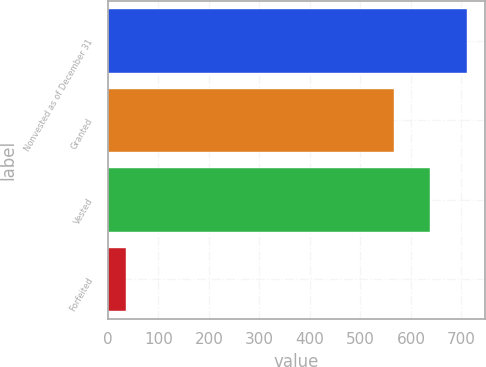Convert chart. <chart><loc_0><loc_0><loc_500><loc_500><bar_chart><fcel>Nonvested as of December 31<fcel>Granted<fcel>Vested<fcel>Forfeited<nl><fcel>710.2<fcel>566<fcel>638.1<fcel>35<nl></chart> 